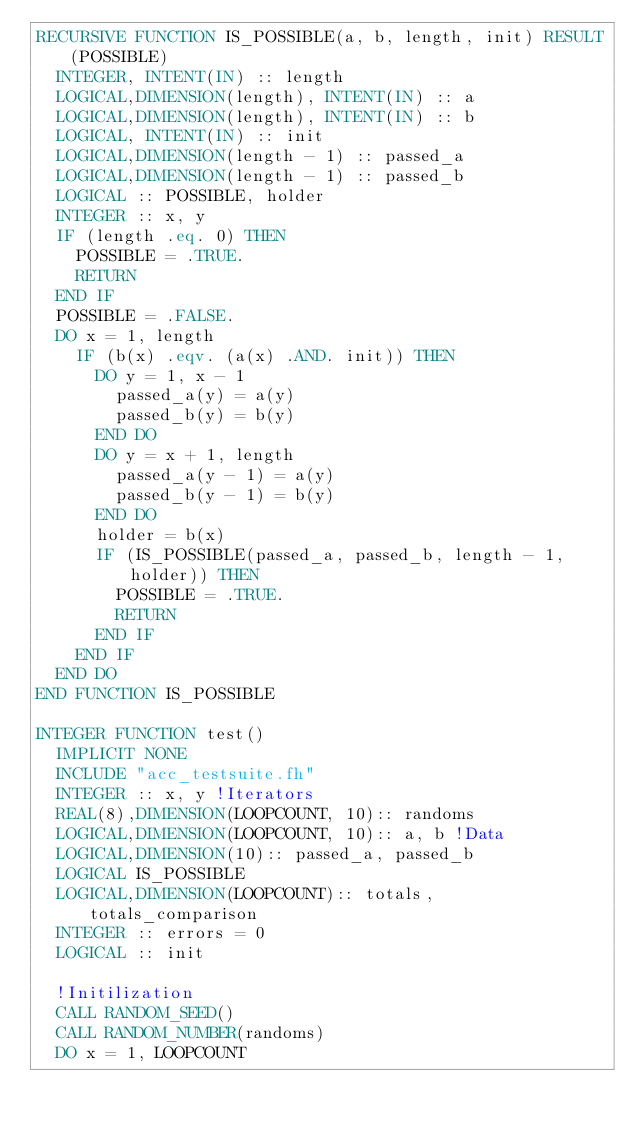Convert code to text. <code><loc_0><loc_0><loc_500><loc_500><_FORTRAN_>RECURSIVE FUNCTION IS_POSSIBLE(a, b, length, init) RESULT(POSSIBLE)
  INTEGER, INTENT(IN) :: length
  LOGICAL,DIMENSION(length), INTENT(IN) :: a
  LOGICAL,DIMENSION(length), INTENT(IN) :: b
  LOGICAL, INTENT(IN) :: init
  LOGICAL,DIMENSION(length - 1) :: passed_a
  LOGICAL,DIMENSION(length - 1) :: passed_b
  LOGICAL :: POSSIBLE, holder
  INTEGER :: x, y
  IF (length .eq. 0) THEN
    POSSIBLE = .TRUE.
    RETURN
  END IF
  POSSIBLE = .FALSE.
  DO x = 1, length
    IF (b(x) .eqv. (a(x) .AND. init)) THEN
      DO y = 1, x - 1
        passed_a(y) = a(y)
        passed_b(y) = b(y)
      END DO
      DO y = x + 1, length
        passed_a(y - 1) = a(y)
        passed_b(y - 1) = b(y)
      END DO
      holder = b(x)
      IF (IS_POSSIBLE(passed_a, passed_b, length - 1, holder)) THEN
        POSSIBLE = .TRUE.
        RETURN
      END IF
    END IF
  END DO
END FUNCTION IS_POSSIBLE

INTEGER FUNCTION test()
  IMPLICIT NONE
  INCLUDE "acc_testsuite.fh"
  INTEGER :: x, y !Iterators
  REAL(8),DIMENSION(LOOPCOUNT, 10):: randoms
  LOGICAL,DIMENSION(LOOPCOUNT, 10):: a, b !Data
  LOGICAL,DIMENSION(10):: passed_a, passed_b
  LOGICAL IS_POSSIBLE
  LOGICAL,DIMENSION(LOOPCOUNT):: totals, totals_comparison
  INTEGER :: errors = 0
  LOGICAL :: init

  !Initilization
  CALL RANDOM_SEED()
  CALL RANDOM_NUMBER(randoms)
  DO x = 1, LOOPCOUNT</code> 